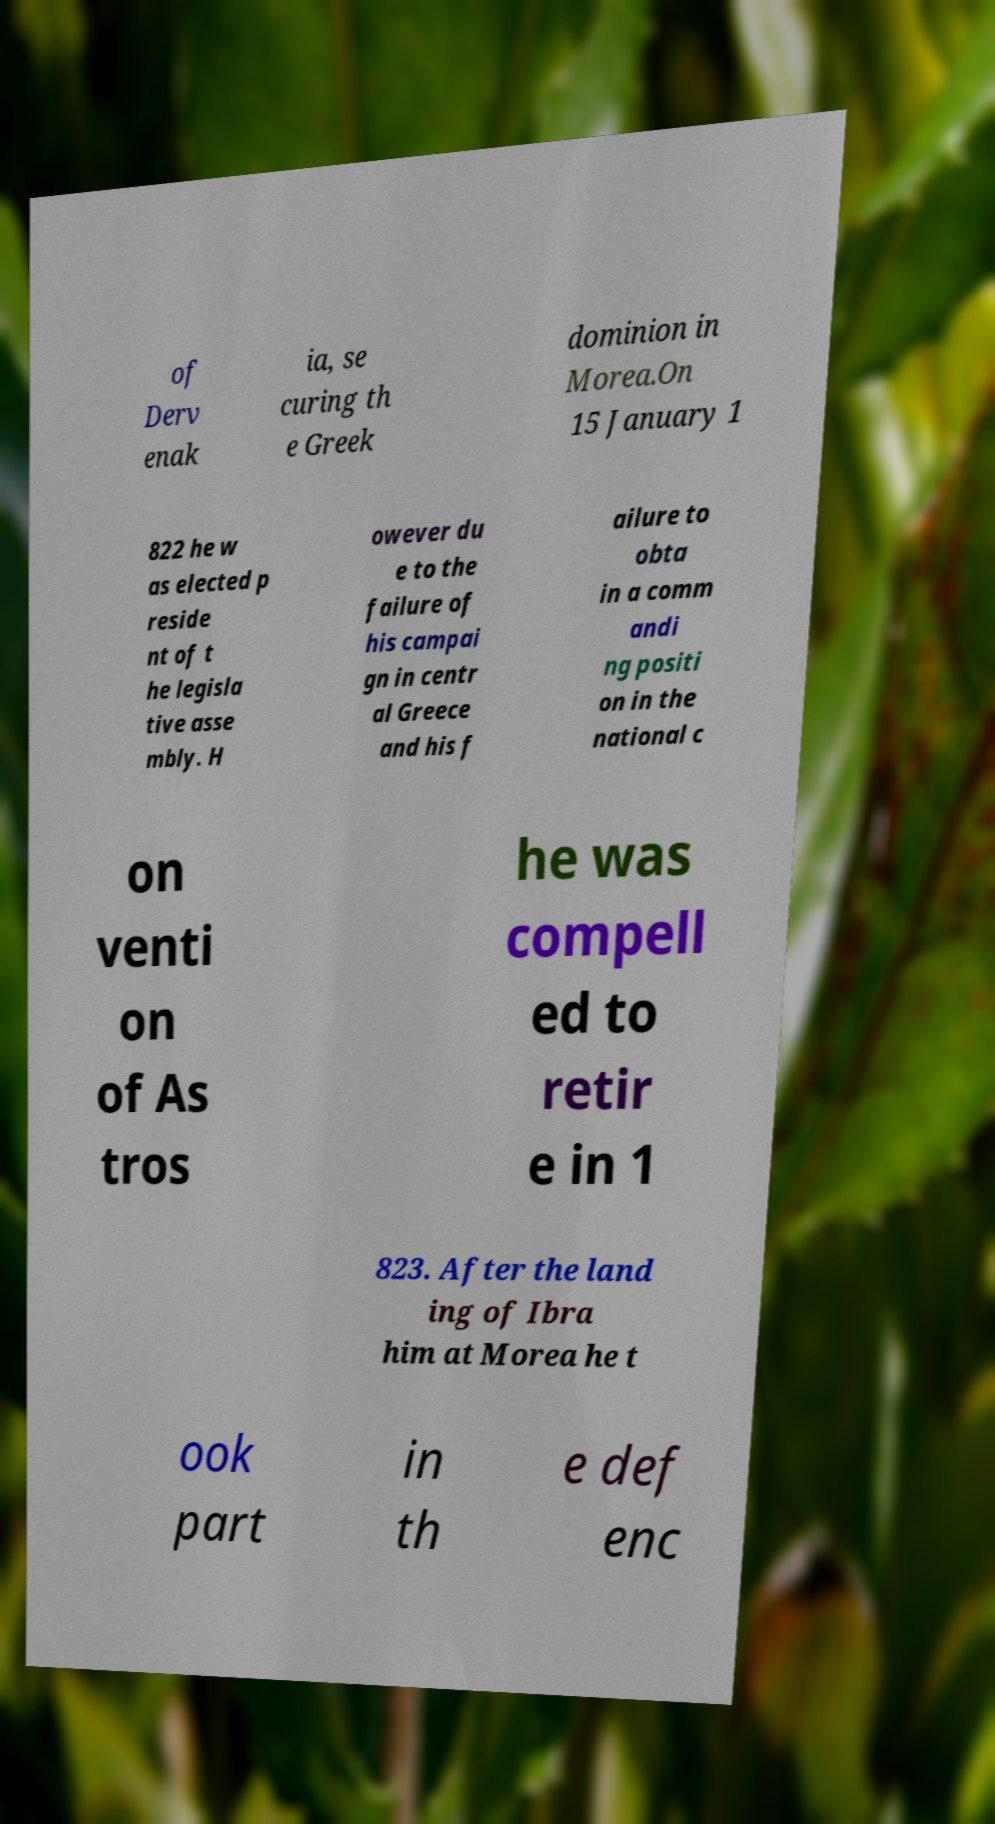Please read and relay the text visible in this image. What does it say? of Derv enak ia, se curing th e Greek dominion in Morea.On 15 January 1 822 he w as elected p reside nt of t he legisla tive asse mbly. H owever du e to the failure of his campai gn in centr al Greece and his f ailure to obta in a comm andi ng positi on in the national c on venti on of As tros he was compell ed to retir e in 1 823. After the land ing of Ibra him at Morea he t ook part in th e def enc 